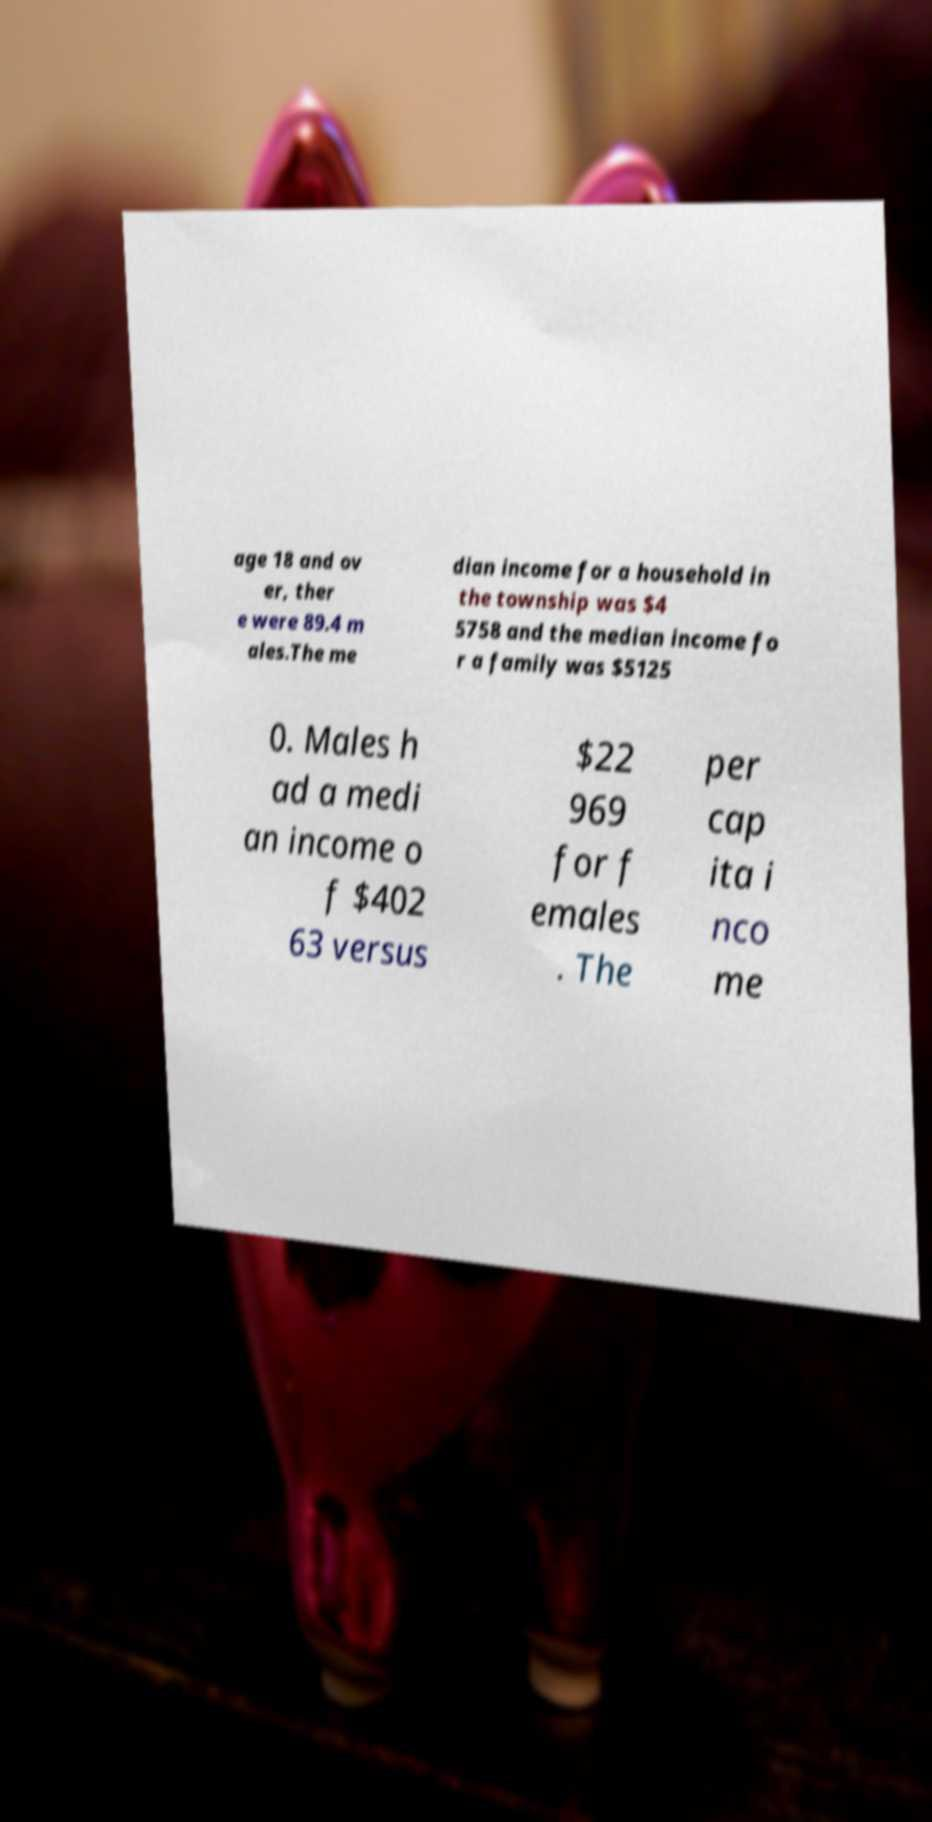Could you assist in decoding the text presented in this image and type it out clearly? age 18 and ov er, ther e were 89.4 m ales.The me dian income for a household in the township was $4 5758 and the median income fo r a family was $5125 0. Males h ad a medi an income o f $402 63 versus $22 969 for f emales . The per cap ita i nco me 